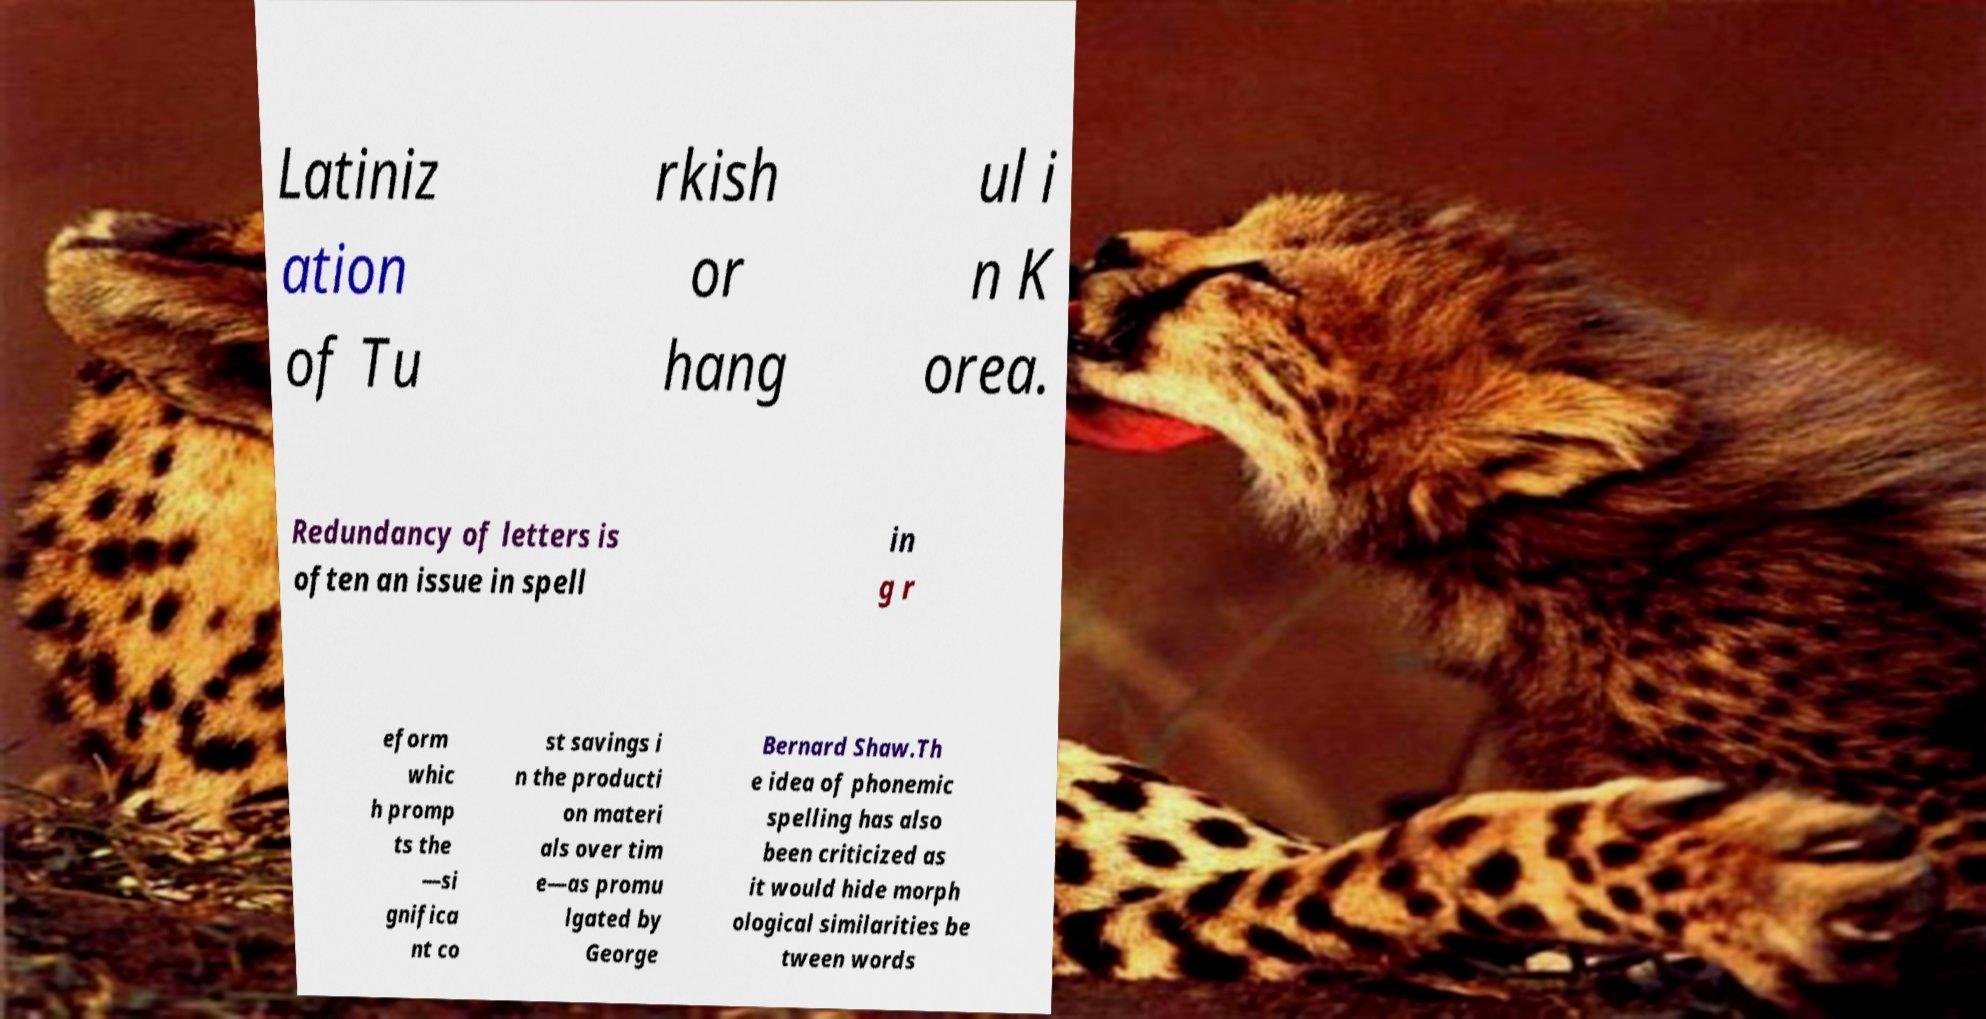Please identify and transcribe the text found in this image. Latiniz ation of Tu rkish or hang ul i n K orea. Redundancy of letters is often an issue in spell in g r eform whic h promp ts the —si gnifica nt co st savings i n the producti on materi als over tim e—as promu lgated by George Bernard Shaw.Th e idea of phonemic spelling has also been criticized as it would hide morph ological similarities be tween words 